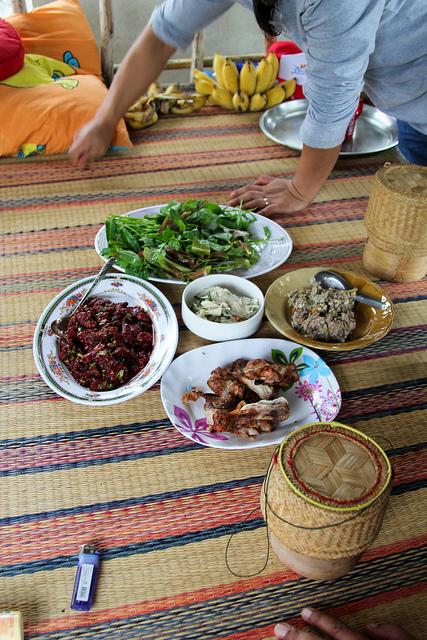What is closest to the person?

Choices:
A) banana
B) barrel
C) baby
D) tiger banana 